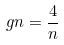<formula> <loc_0><loc_0><loc_500><loc_500>g n = \frac { 4 } { n }</formula> 